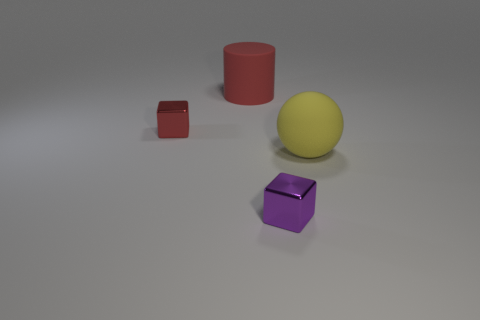There is a cube on the left side of the big cylinder; what number of red rubber objects are in front of it?
Your answer should be very brief. 0. What material is the other tiny thing that is the same shape as the red metallic thing?
Offer a terse response. Metal. What is the color of the rubber sphere?
Provide a short and direct response. Yellow. What number of things are red rubber cubes or purple shiny cubes?
Ensure brevity in your answer.  1. There is a small object that is to the right of the small red shiny thing that is in front of the large red matte cylinder; what is its shape?
Offer a very short reply. Cube. How many other things are made of the same material as the purple block?
Ensure brevity in your answer.  1. Are the purple object and the tiny red cube left of the rubber cylinder made of the same material?
Your answer should be compact. Yes. What number of things are either metal blocks that are behind the large yellow object or shiny objects behind the big yellow matte thing?
Your answer should be very brief. 1. How many other objects are the same color as the large cylinder?
Provide a short and direct response. 1. Are there more big things that are to the left of the small purple metallic thing than blocks in front of the yellow thing?
Offer a very short reply. No. 